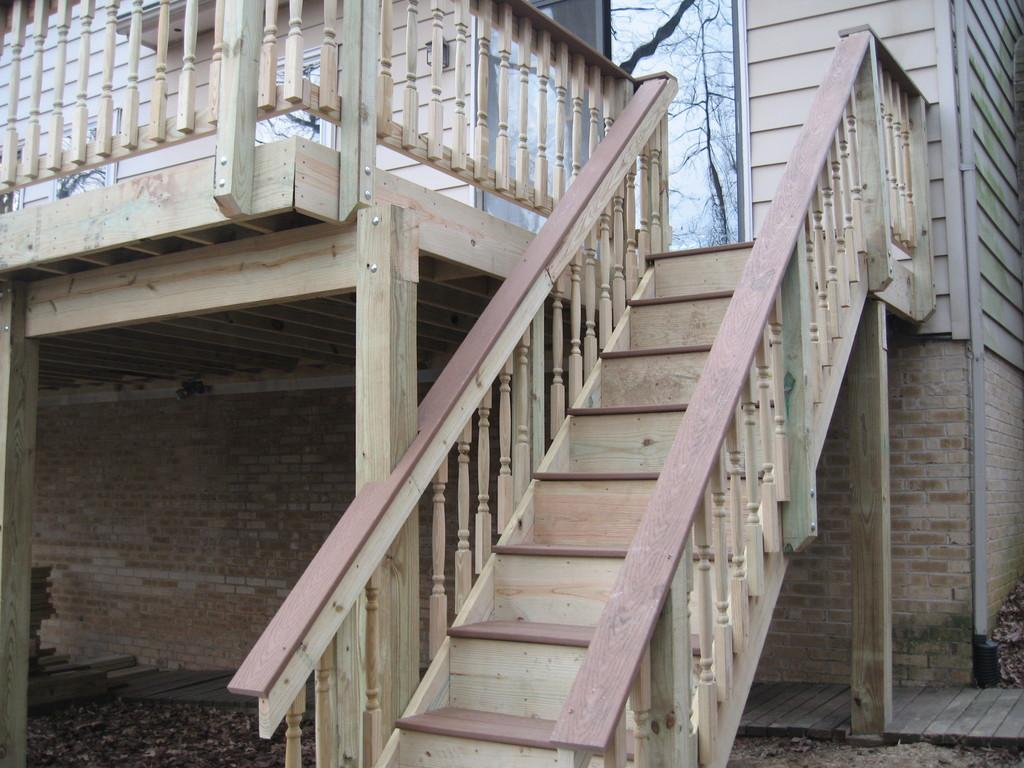What type of home is depicted in the image? There is a wooden home in the image. What feature can be seen in the middle of the wooden home? The wooden home has a staircase in the middle. Is there a door visible in the image? Yes, there is a glass door in the back of the wooden home. What type of bridge can be seen connecting the wooden home to the neighboring house in the image? There is no bridge connecting the wooden home to a neighboring house in the image. How does the bulb in the image react to the sunlight? There is no bulb present in the image. 